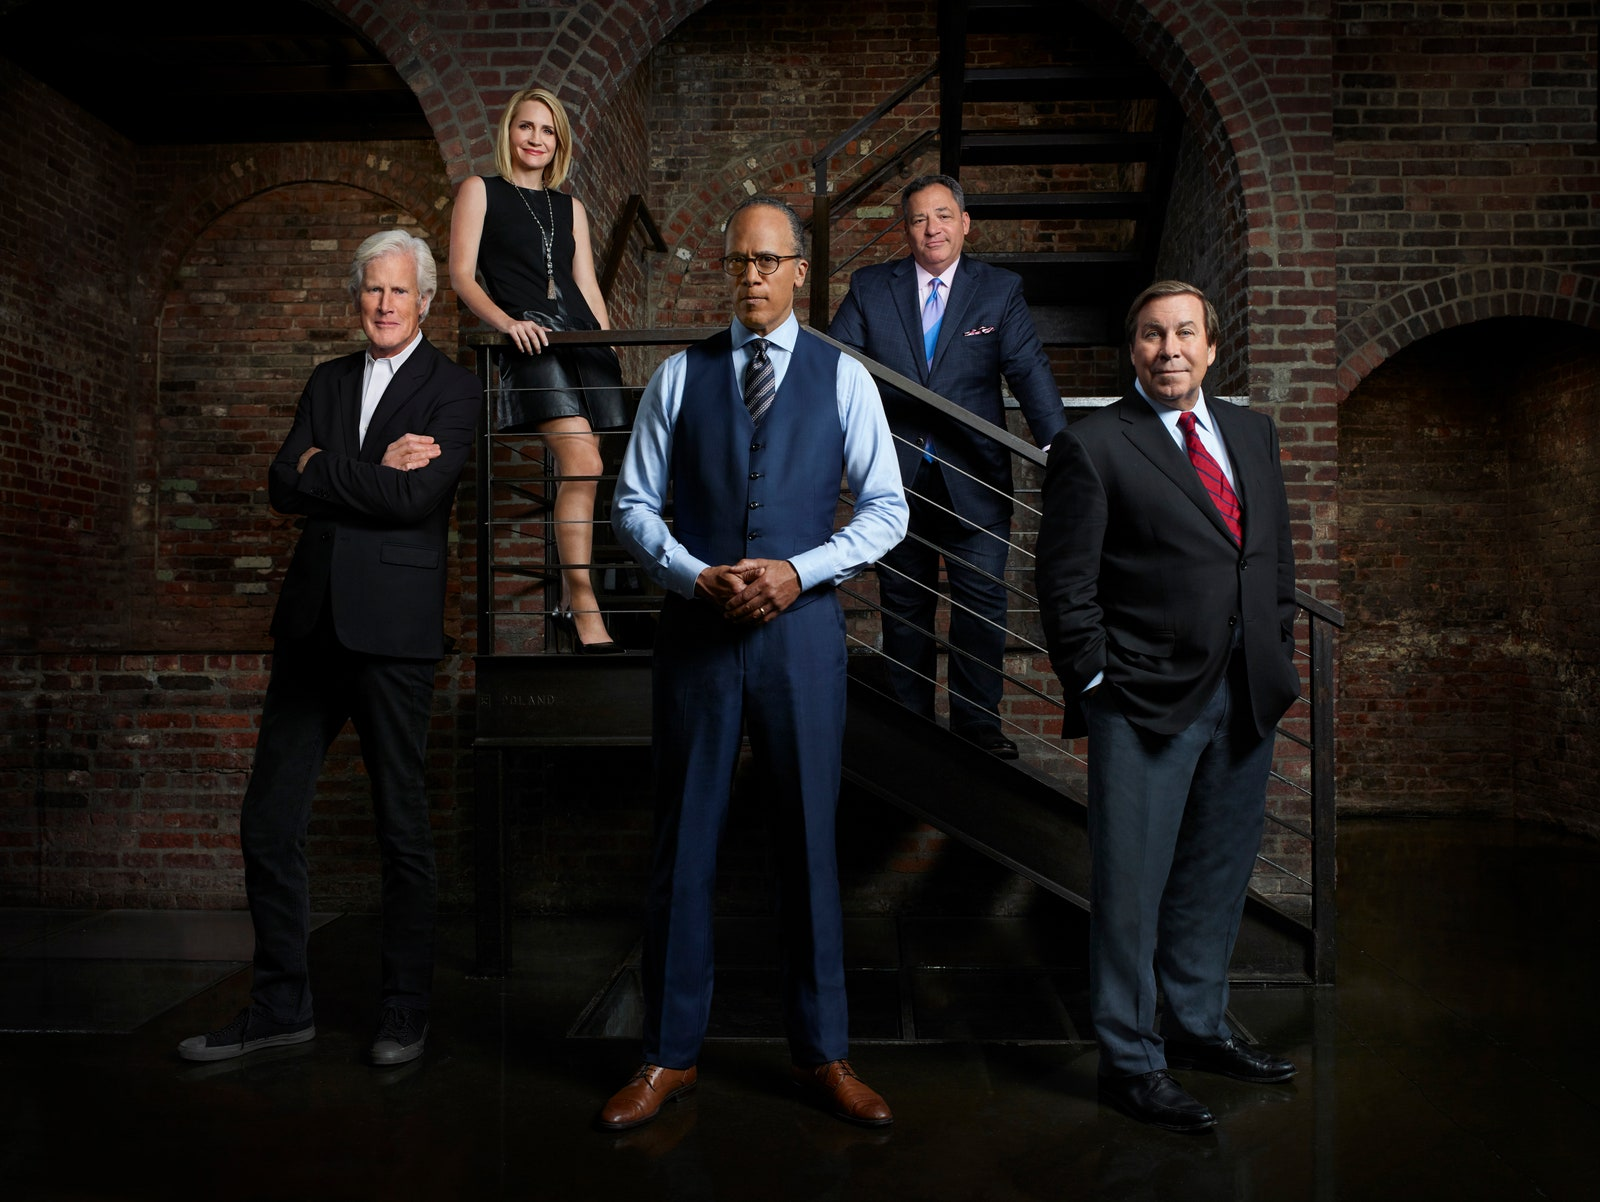What kind of business or industry do you think these individuals are a part of, based on their appearance and the setting? Based on their formal attire and the industrial brick wall background, it is likely that they are part of a traditional corporate industry such as finance, law, or consulting. The serious expressions and confident poses suggest high-level professionals who may hold influential positions within their organization. Could this setting be indicative of any specific company's culture or brand? Yes, the industrial and somewhat rustic setting combined with their formal dress code could be indicative of a company that values tradition and sophistication while also embracing a modern and dynamic atmosphere. It could be a firm that prides itself on its rich history and solid reputation while also aiming to convey an image of adaptability and forward-thinking. If you had to guess, what type of list or page on the company’s website would this photograph likely appear on? This photograph would likely appear on the 'About Us' or 'Leadership Team' page of the company's website. It could also be featured in the 'Corporate Culture' or 'History and Values' sections, illustrating the company's strong leadership and the cohesive nature of the executive team, giving visitors an insight into who drives the company forward. 